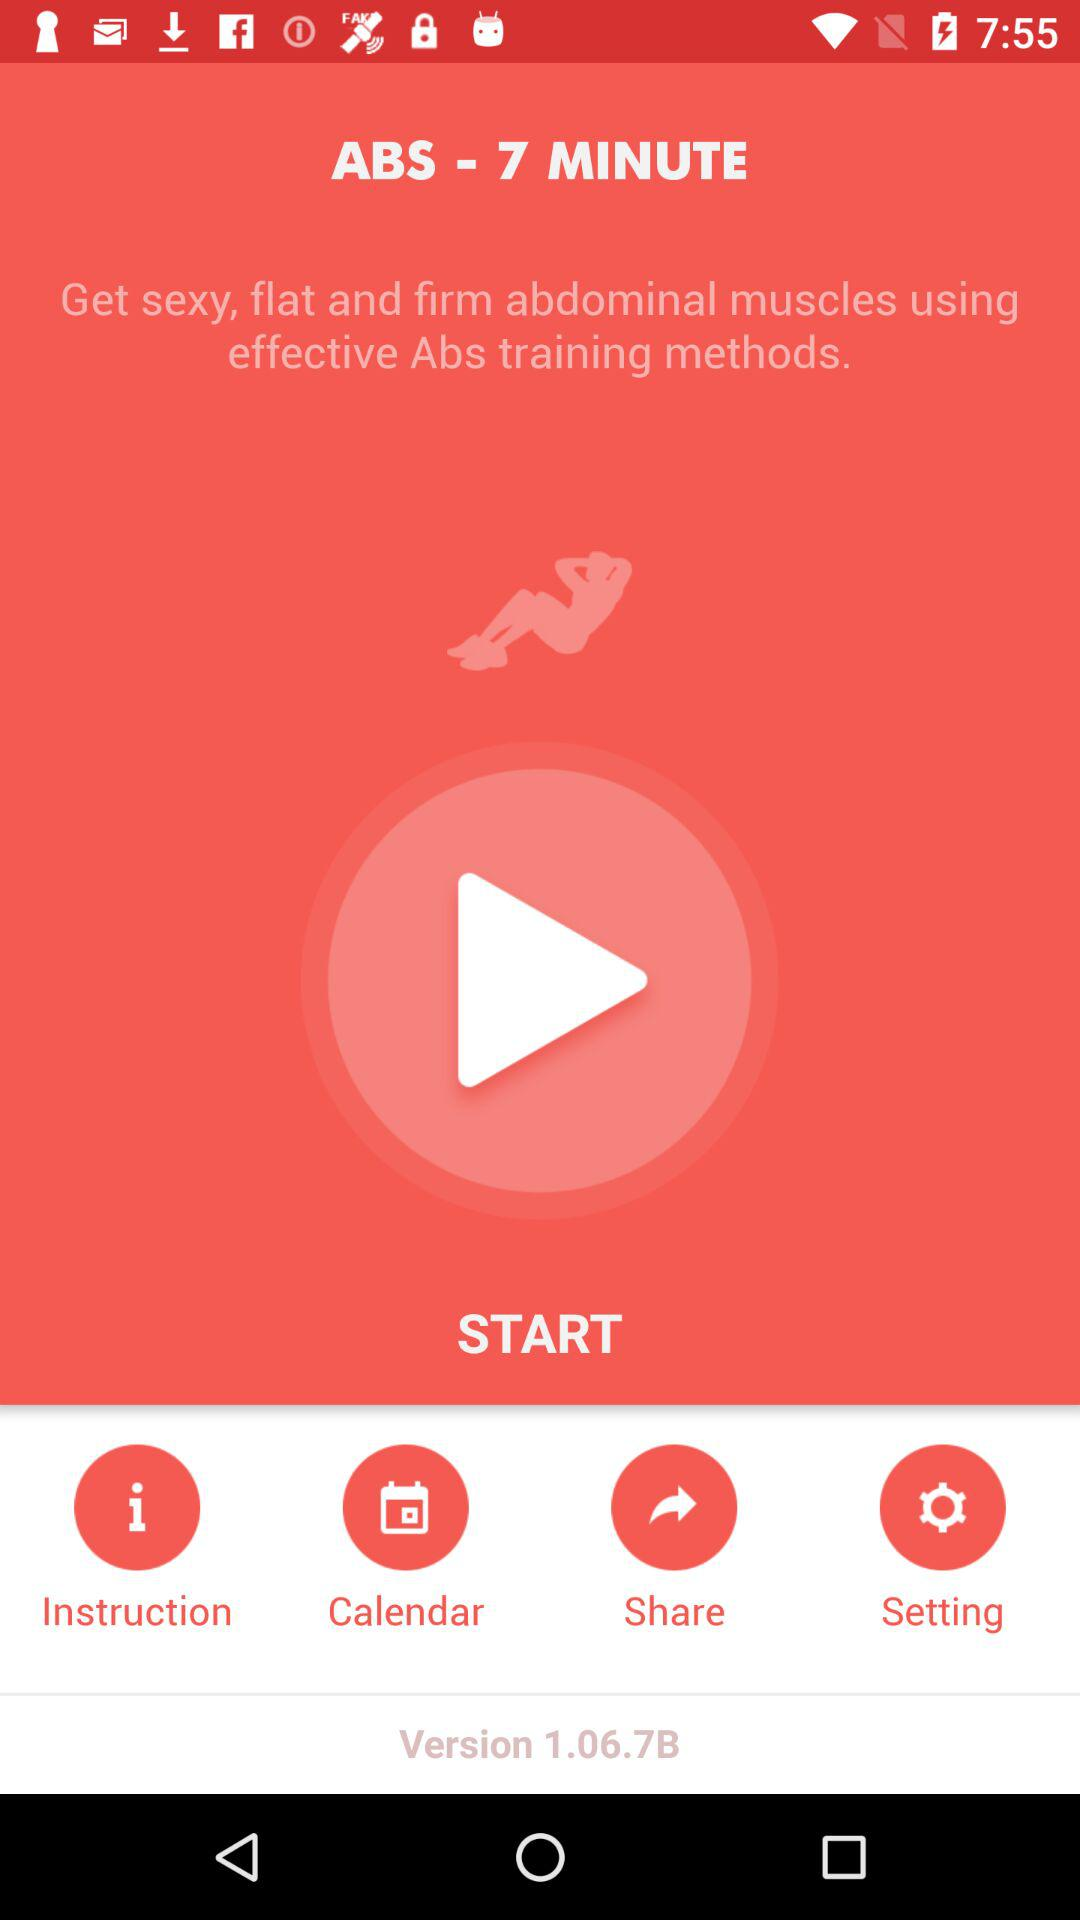Which days on the calendar are set aside for working out?
When the provided information is insufficient, respond with <no answer>. <no answer> 